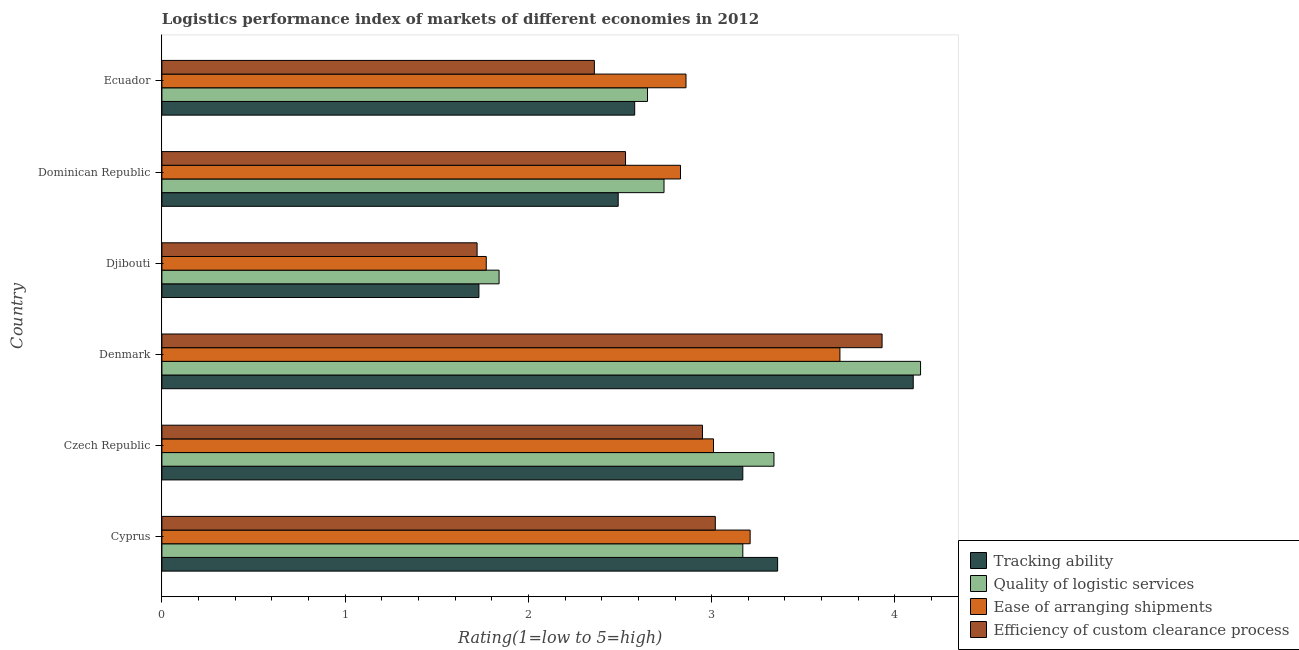How many groups of bars are there?
Give a very brief answer. 6. Are the number of bars per tick equal to the number of legend labels?
Provide a succinct answer. Yes. What is the label of the 2nd group of bars from the top?
Your answer should be compact. Dominican Republic. In how many cases, is the number of bars for a given country not equal to the number of legend labels?
Offer a very short reply. 0. What is the lpi rating of tracking ability in Czech Republic?
Your answer should be compact. 3.17. Across all countries, what is the maximum lpi rating of quality of logistic services?
Give a very brief answer. 4.14. Across all countries, what is the minimum lpi rating of ease of arranging shipments?
Offer a terse response. 1.77. In which country was the lpi rating of quality of logistic services minimum?
Ensure brevity in your answer.  Djibouti. What is the total lpi rating of quality of logistic services in the graph?
Offer a terse response. 17.88. What is the difference between the lpi rating of efficiency of custom clearance process in Denmark and that in Djibouti?
Provide a succinct answer. 2.21. What is the difference between the lpi rating of ease of arranging shipments in Dominican Republic and the lpi rating of tracking ability in Denmark?
Your answer should be compact. -1.27. What is the average lpi rating of efficiency of custom clearance process per country?
Offer a very short reply. 2.75. What is the difference between the lpi rating of quality of logistic services and lpi rating of ease of arranging shipments in Ecuador?
Your answer should be compact. -0.21. What is the ratio of the lpi rating of ease of arranging shipments in Djibouti to that in Dominican Republic?
Ensure brevity in your answer.  0.62. Is the lpi rating of efficiency of custom clearance process in Denmark less than that in Dominican Republic?
Make the answer very short. No. Is the difference between the lpi rating of efficiency of custom clearance process in Czech Republic and Denmark greater than the difference between the lpi rating of ease of arranging shipments in Czech Republic and Denmark?
Ensure brevity in your answer.  No. What is the difference between the highest and the second highest lpi rating of ease of arranging shipments?
Your answer should be very brief. 0.49. What is the difference between the highest and the lowest lpi rating of efficiency of custom clearance process?
Give a very brief answer. 2.21. In how many countries, is the lpi rating of quality of logistic services greater than the average lpi rating of quality of logistic services taken over all countries?
Give a very brief answer. 3. Is the sum of the lpi rating of tracking ability in Djibouti and Dominican Republic greater than the maximum lpi rating of ease of arranging shipments across all countries?
Provide a short and direct response. Yes. Is it the case that in every country, the sum of the lpi rating of ease of arranging shipments and lpi rating of tracking ability is greater than the sum of lpi rating of efficiency of custom clearance process and lpi rating of quality of logistic services?
Offer a very short reply. No. What does the 4th bar from the top in Dominican Republic represents?
Ensure brevity in your answer.  Tracking ability. What does the 4th bar from the bottom in Djibouti represents?
Your answer should be compact. Efficiency of custom clearance process. How many countries are there in the graph?
Give a very brief answer. 6. What is the difference between two consecutive major ticks on the X-axis?
Offer a very short reply. 1. Where does the legend appear in the graph?
Ensure brevity in your answer.  Bottom right. How are the legend labels stacked?
Your answer should be compact. Vertical. What is the title of the graph?
Offer a terse response. Logistics performance index of markets of different economies in 2012. Does "European Union" appear as one of the legend labels in the graph?
Keep it short and to the point. No. What is the label or title of the X-axis?
Your answer should be compact. Rating(1=low to 5=high). What is the Rating(1=low to 5=high) of Tracking ability in Cyprus?
Make the answer very short. 3.36. What is the Rating(1=low to 5=high) of Quality of logistic services in Cyprus?
Give a very brief answer. 3.17. What is the Rating(1=low to 5=high) of Ease of arranging shipments in Cyprus?
Keep it short and to the point. 3.21. What is the Rating(1=low to 5=high) of Efficiency of custom clearance process in Cyprus?
Keep it short and to the point. 3.02. What is the Rating(1=low to 5=high) of Tracking ability in Czech Republic?
Ensure brevity in your answer.  3.17. What is the Rating(1=low to 5=high) in Quality of logistic services in Czech Republic?
Make the answer very short. 3.34. What is the Rating(1=low to 5=high) in Ease of arranging shipments in Czech Republic?
Provide a short and direct response. 3.01. What is the Rating(1=low to 5=high) of Efficiency of custom clearance process in Czech Republic?
Offer a terse response. 2.95. What is the Rating(1=low to 5=high) of Tracking ability in Denmark?
Your response must be concise. 4.1. What is the Rating(1=low to 5=high) of Quality of logistic services in Denmark?
Make the answer very short. 4.14. What is the Rating(1=low to 5=high) of Ease of arranging shipments in Denmark?
Keep it short and to the point. 3.7. What is the Rating(1=low to 5=high) in Efficiency of custom clearance process in Denmark?
Keep it short and to the point. 3.93. What is the Rating(1=low to 5=high) in Tracking ability in Djibouti?
Your answer should be very brief. 1.73. What is the Rating(1=low to 5=high) of Quality of logistic services in Djibouti?
Your answer should be very brief. 1.84. What is the Rating(1=low to 5=high) in Ease of arranging shipments in Djibouti?
Ensure brevity in your answer.  1.77. What is the Rating(1=low to 5=high) in Efficiency of custom clearance process in Djibouti?
Provide a short and direct response. 1.72. What is the Rating(1=low to 5=high) in Tracking ability in Dominican Republic?
Give a very brief answer. 2.49. What is the Rating(1=low to 5=high) in Quality of logistic services in Dominican Republic?
Ensure brevity in your answer.  2.74. What is the Rating(1=low to 5=high) in Ease of arranging shipments in Dominican Republic?
Make the answer very short. 2.83. What is the Rating(1=low to 5=high) of Efficiency of custom clearance process in Dominican Republic?
Give a very brief answer. 2.53. What is the Rating(1=low to 5=high) of Tracking ability in Ecuador?
Provide a succinct answer. 2.58. What is the Rating(1=low to 5=high) in Quality of logistic services in Ecuador?
Offer a very short reply. 2.65. What is the Rating(1=low to 5=high) in Ease of arranging shipments in Ecuador?
Offer a very short reply. 2.86. What is the Rating(1=low to 5=high) in Efficiency of custom clearance process in Ecuador?
Ensure brevity in your answer.  2.36. Across all countries, what is the maximum Rating(1=low to 5=high) in Quality of logistic services?
Provide a short and direct response. 4.14. Across all countries, what is the maximum Rating(1=low to 5=high) in Ease of arranging shipments?
Make the answer very short. 3.7. Across all countries, what is the maximum Rating(1=low to 5=high) in Efficiency of custom clearance process?
Keep it short and to the point. 3.93. Across all countries, what is the minimum Rating(1=low to 5=high) in Tracking ability?
Keep it short and to the point. 1.73. Across all countries, what is the minimum Rating(1=low to 5=high) in Quality of logistic services?
Offer a very short reply. 1.84. Across all countries, what is the minimum Rating(1=low to 5=high) of Ease of arranging shipments?
Ensure brevity in your answer.  1.77. Across all countries, what is the minimum Rating(1=low to 5=high) in Efficiency of custom clearance process?
Your answer should be very brief. 1.72. What is the total Rating(1=low to 5=high) in Tracking ability in the graph?
Give a very brief answer. 17.43. What is the total Rating(1=low to 5=high) in Quality of logistic services in the graph?
Provide a short and direct response. 17.88. What is the total Rating(1=low to 5=high) of Ease of arranging shipments in the graph?
Offer a terse response. 17.38. What is the total Rating(1=low to 5=high) of Efficiency of custom clearance process in the graph?
Keep it short and to the point. 16.51. What is the difference between the Rating(1=low to 5=high) of Tracking ability in Cyprus and that in Czech Republic?
Provide a short and direct response. 0.19. What is the difference between the Rating(1=low to 5=high) in Quality of logistic services in Cyprus and that in Czech Republic?
Offer a terse response. -0.17. What is the difference between the Rating(1=low to 5=high) in Efficiency of custom clearance process in Cyprus and that in Czech Republic?
Your answer should be compact. 0.07. What is the difference between the Rating(1=low to 5=high) in Tracking ability in Cyprus and that in Denmark?
Give a very brief answer. -0.74. What is the difference between the Rating(1=low to 5=high) of Quality of logistic services in Cyprus and that in Denmark?
Offer a very short reply. -0.97. What is the difference between the Rating(1=low to 5=high) of Ease of arranging shipments in Cyprus and that in Denmark?
Your response must be concise. -0.49. What is the difference between the Rating(1=low to 5=high) of Efficiency of custom clearance process in Cyprus and that in Denmark?
Offer a terse response. -0.91. What is the difference between the Rating(1=low to 5=high) in Tracking ability in Cyprus and that in Djibouti?
Make the answer very short. 1.63. What is the difference between the Rating(1=low to 5=high) in Quality of logistic services in Cyprus and that in Djibouti?
Keep it short and to the point. 1.33. What is the difference between the Rating(1=low to 5=high) of Ease of arranging shipments in Cyprus and that in Djibouti?
Your response must be concise. 1.44. What is the difference between the Rating(1=low to 5=high) of Efficiency of custom clearance process in Cyprus and that in Djibouti?
Your answer should be very brief. 1.3. What is the difference between the Rating(1=low to 5=high) in Tracking ability in Cyprus and that in Dominican Republic?
Offer a terse response. 0.87. What is the difference between the Rating(1=low to 5=high) in Quality of logistic services in Cyprus and that in Dominican Republic?
Your answer should be very brief. 0.43. What is the difference between the Rating(1=low to 5=high) in Ease of arranging shipments in Cyprus and that in Dominican Republic?
Your answer should be compact. 0.38. What is the difference between the Rating(1=low to 5=high) of Efficiency of custom clearance process in Cyprus and that in Dominican Republic?
Ensure brevity in your answer.  0.49. What is the difference between the Rating(1=low to 5=high) in Tracking ability in Cyprus and that in Ecuador?
Give a very brief answer. 0.78. What is the difference between the Rating(1=low to 5=high) in Quality of logistic services in Cyprus and that in Ecuador?
Provide a short and direct response. 0.52. What is the difference between the Rating(1=low to 5=high) of Ease of arranging shipments in Cyprus and that in Ecuador?
Provide a succinct answer. 0.35. What is the difference between the Rating(1=low to 5=high) in Efficiency of custom clearance process in Cyprus and that in Ecuador?
Give a very brief answer. 0.66. What is the difference between the Rating(1=low to 5=high) of Tracking ability in Czech Republic and that in Denmark?
Keep it short and to the point. -0.93. What is the difference between the Rating(1=low to 5=high) in Ease of arranging shipments in Czech Republic and that in Denmark?
Keep it short and to the point. -0.69. What is the difference between the Rating(1=low to 5=high) in Efficiency of custom clearance process in Czech Republic and that in Denmark?
Offer a terse response. -0.98. What is the difference between the Rating(1=low to 5=high) in Tracking ability in Czech Republic and that in Djibouti?
Your answer should be compact. 1.44. What is the difference between the Rating(1=low to 5=high) of Ease of arranging shipments in Czech Republic and that in Djibouti?
Provide a succinct answer. 1.24. What is the difference between the Rating(1=low to 5=high) in Efficiency of custom clearance process in Czech Republic and that in Djibouti?
Make the answer very short. 1.23. What is the difference between the Rating(1=low to 5=high) of Tracking ability in Czech Republic and that in Dominican Republic?
Offer a very short reply. 0.68. What is the difference between the Rating(1=low to 5=high) in Quality of logistic services in Czech Republic and that in Dominican Republic?
Your answer should be very brief. 0.6. What is the difference between the Rating(1=low to 5=high) of Ease of arranging shipments in Czech Republic and that in Dominican Republic?
Your answer should be compact. 0.18. What is the difference between the Rating(1=low to 5=high) in Efficiency of custom clearance process in Czech Republic and that in Dominican Republic?
Provide a succinct answer. 0.42. What is the difference between the Rating(1=low to 5=high) in Tracking ability in Czech Republic and that in Ecuador?
Ensure brevity in your answer.  0.59. What is the difference between the Rating(1=low to 5=high) in Quality of logistic services in Czech Republic and that in Ecuador?
Offer a terse response. 0.69. What is the difference between the Rating(1=low to 5=high) in Efficiency of custom clearance process in Czech Republic and that in Ecuador?
Ensure brevity in your answer.  0.59. What is the difference between the Rating(1=low to 5=high) of Tracking ability in Denmark and that in Djibouti?
Your answer should be very brief. 2.37. What is the difference between the Rating(1=low to 5=high) of Quality of logistic services in Denmark and that in Djibouti?
Your response must be concise. 2.3. What is the difference between the Rating(1=low to 5=high) of Ease of arranging shipments in Denmark and that in Djibouti?
Provide a succinct answer. 1.93. What is the difference between the Rating(1=low to 5=high) of Efficiency of custom clearance process in Denmark and that in Djibouti?
Make the answer very short. 2.21. What is the difference between the Rating(1=low to 5=high) in Tracking ability in Denmark and that in Dominican Republic?
Give a very brief answer. 1.61. What is the difference between the Rating(1=low to 5=high) of Quality of logistic services in Denmark and that in Dominican Republic?
Your answer should be very brief. 1.4. What is the difference between the Rating(1=low to 5=high) in Ease of arranging shipments in Denmark and that in Dominican Republic?
Keep it short and to the point. 0.87. What is the difference between the Rating(1=low to 5=high) in Tracking ability in Denmark and that in Ecuador?
Your response must be concise. 1.52. What is the difference between the Rating(1=low to 5=high) in Quality of logistic services in Denmark and that in Ecuador?
Offer a very short reply. 1.49. What is the difference between the Rating(1=low to 5=high) in Ease of arranging shipments in Denmark and that in Ecuador?
Give a very brief answer. 0.84. What is the difference between the Rating(1=low to 5=high) of Efficiency of custom clearance process in Denmark and that in Ecuador?
Ensure brevity in your answer.  1.57. What is the difference between the Rating(1=low to 5=high) in Tracking ability in Djibouti and that in Dominican Republic?
Give a very brief answer. -0.76. What is the difference between the Rating(1=low to 5=high) of Ease of arranging shipments in Djibouti and that in Dominican Republic?
Make the answer very short. -1.06. What is the difference between the Rating(1=low to 5=high) in Efficiency of custom clearance process in Djibouti and that in Dominican Republic?
Provide a succinct answer. -0.81. What is the difference between the Rating(1=low to 5=high) of Tracking ability in Djibouti and that in Ecuador?
Offer a very short reply. -0.85. What is the difference between the Rating(1=low to 5=high) in Quality of logistic services in Djibouti and that in Ecuador?
Provide a short and direct response. -0.81. What is the difference between the Rating(1=low to 5=high) in Ease of arranging shipments in Djibouti and that in Ecuador?
Give a very brief answer. -1.09. What is the difference between the Rating(1=low to 5=high) in Efficiency of custom clearance process in Djibouti and that in Ecuador?
Your answer should be very brief. -0.64. What is the difference between the Rating(1=low to 5=high) of Tracking ability in Dominican Republic and that in Ecuador?
Offer a terse response. -0.09. What is the difference between the Rating(1=low to 5=high) in Quality of logistic services in Dominican Republic and that in Ecuador?
Your response must be concise. 0.09. What is the difference between the Rating(1=low to 5=high) of Ease of arranging shipments in Dominican Republic and that in Ecuador?
Provide a succinct answer. -0.03. What is the difference between the Rating(1=low to 5=high) of Efficiency of custom clearance process in Dominican Republic and that in Ecuador?
Your answer should be very brief. 0.17. What is the difference between the Rating(1=low to 5=high) in Tracking ability in Cyprus and the Rating(1=low to 5=high) in Efficiency of custom clearance process in Czech Republic?
Provide a short and direct response. 0.41. What is the difference between the Rating(1=low to 5=high) in Quality of logistic services in Cyprus and the Rating(1=low to 5=high) in Ease of arranging shipments in Czech Republic?
Provide a succinct answer. 0.16. What is the difference between the Rating(1=low to 5=high) of Quality of logistic services in Cyprus and the Rating(1=low to 5=high) of Efficiency of custom clearance process in Czech Republic?
Keep it short and to the point. 0.22. What is the difference between the Rating(1=low to 5=high) in Ease of arranging shipments in Cyprus and the Rating(1=low to 5=high) in Efficiency of custom clearance process in Czech Republic?
Your response must be concise. 0.26. What is the difference between the Rating(1=low to 5=high) of Tracking ability in Cyprus and the Rating(1=low to 5=high) of Quality of logistic services in Denmark?
Provide a short and direct response. -0.78. What is the difference between the Rating(1=low to 5=high) of Tracking ability in Cyprus and the Rating(1=low to 5=high) of Ease of arranging shipments in Denmark?
Offer a very short reply. -0.34. What is the difference between the Rating(1=low to 5=high) of Tracking ability in Cyprus and the Rating(1=low to 5=high) of Efficiency of custom clearance process in Denmark?
Provide a short and direct response. -0.57. What is the difference between the Rating(1=low to 5=high) of Quality of logistic services in Cyprus and the Rating(1=low to 5=high) of Ease of arranging shipments in Denmark?
Keep it short and to the point. -0.53. What is the difference between the Rating(1=low to 5=high) in Quality of logistic services in Cyprus and the Rating(1=low to 5=high) in Efficiency of custom clearance process in Denmark?
Your answer should be very brief. -0.76. What is the difference between the Rating(1=low to 5=high) in Ease of arranging shipments in Cyprus and the Rating(1=low to 5=high) in Efficiency of custom clearance process in Denmark?
Offer a terse response. -0.72. What is the difference between the Rating(1=low to 5=high) of Tracking ability in Cyprus and the Rating(1=low to 5=high) of Quality of logistic services in Djibouti?
Your answer should be very brief. 1.52. What is the difference between the Rating(1=low to 5=high) of Tracking ability in Cyprus and the Rating(1=low to 5=high) of Ease of arranging shipments in Djibouti?
Make the answer very short. 1.59. What is the difference between the Rating(1=low to 5=high) of Tracking ability in Cyprus and the Rating(1=low to 5=high) of Efficiency of custom clearance process in Djibouti?
Offer a terse response. 1.64. What is the difference between the Rating(1=low to 5=high) of Quality of logistic services in Cyprus and the Rating(1=low to 5=high) of Efficiency of custom clearance process in Djibouti?
Provide a short and direct response. 1.45. What is the difference between the Rating(1=low to 5=high) of Ease of arranging shipments in Cyprus and the Rating(1=low to 5=high) of Efficiency of custom clearance process in Djibouti?
Make the answer very short. 1.49. What is the difference between the Rating(1=low to 5=high) in Tracking ability in Cyprus and the Rating(1=low to 5=high) in Quality of logistic services in Dominican Republic?
Your answer should be compact. 0.62. What is the difference between the Rating(1=low to 5=high) of Tracking ability in Cyprus and the Rating(1=low to 5=high) of Ease of arranging shipments in Dominican Republic?
Give a very brief answer. 0.53. What is the difference between the Rating(1=low to 5=high) of Tracking ability in Cyprus and the Rating(1=low to 5=high) of Efficiency of custom clearance process in Dominican Republic?
Your answer should be very brief. 0.83. What is the difference between the Rating(1=low to 5=high) in Quality of logistic services in Cyprus and the Rating(1=low to 5=high) in Ease of arranging shipments in Dominican Republic?
Ensure brevity in your answer.  0.34. What is the difference between the Rating(1=low to 5=high) of Quality of logistic services in Cyprus and the Rating(1=low to 5=high) of Efficiency of custom clearance process in Dominican Republic?
Offer a terse response. 0.64. What is the difference between the Rating(1=low to 5=high) of Ease of arranging shipments in Cyprus and the Rating(1=low to 5=high) of Efficiency of custom clearance process in Dominican Republic?
Provide a short and direct response. 0.68. What is the difference between the Rating(1=low to 5=high) in Tracking ability in Cyprus and the Rating(1=low to 5=high) in Quality of logistic services in Ecuador?
Ensure brevity in your answer.  0.71. What is the difference between the Rating(1=low to 5=high) of Quality of logistic services in Cyprus and the Rating(1=low to 5=high) of Ease of arranging shipments in Ecuador?
Your answer should be compact. 0.31. What is the difference between the Rating(1=low to 5=high) of Quality of logistic services in Cyprus and the Rating(1=low to 5=high) of Efficiency of custom clearance process in Ecuador?
Offer a very short reply. 0.81. What is the difference between the Rating(1=low to 5=high) of Tracking ability in Czech Republic and the Rating(1=low to 5=high) of Quality of logistic services in Denmark?
Make the answer very short. -0.97. What is the difference between the Rating(1=low to 5=high) of Tracking ability in Czech Republic and the Rating(1=low to 5=high) of Ease of arranging shipments in Denmark?
Keep it short and to the point. -0.53. What is the difference between the Rating(1=low to 5=high) in Tracking ability in Czech Republic and the Rating(1=low to 5=high) in Efficiency of custom clearance process in Denmark?
Provide a succinct answer. -0.76. What is the difference between the Rating(1=low to 5=high) of Quality of logistic services in Czech Republic and the Rating(1=low to 5=high) of Ease of arranging shipments in Denmark?
Provide a short and direct response. -0.36. What is the difference between the Rating(1=low to 5=high) of Quality of logistic services in Czech Republic and the Rating(1=low to 5=high) of Efficiency of custom clearance process in Denmark?
Your answer should be very brief. -0.59. What is the difference between the Rating(1=low to 5=high) in Ease of arranging shipments in Czech Republic and the Rating(1=low to 5=high) in Efficiency of custom clearance process in Denmark?
Keep it short and to the point. -0.92. What is the difference between the Rating(1=low to 5=high) of Tracking ability in Czech Republic and the Rating(1=low to 5=high) of Quality of logistic services in Djibouti?
Make the answer very short. 1.33. What is the difference between the Rating(1=low to 5=high) in Tracking ability in Czech Republic and the Rating(1=low to 5=high) in Efficiency of custom clearance process in Djibouti?
Ensure brevity in your answer.  1.45. What is the difference between the Rating(1=low to 5=high) in Quality of logistic services in Czech Republic and the Rating(1=low to 5=high) in Ease of arranging shipments in Djibouti?
Make the answer very short. 1.57. What is the difference between the Rating(1=low to 5=high) in Quality of logistic services in Czech Republic and the Rating(1=low to 5=high) in Efficiency of custom clearance process in Djibouti?
Provide a succinct answer. 1.62. What is the difference between the Rating(1=low to 5=high) of Ease of arranging shipments in Czech Republic and the Rating(1=low to 5=high) of Efficiency of custom clearance process in Djibouti?
Offer a terse response. 1.29. What is the difference between the Rating(1=low to 5=high) in Tracking ability in Czech Republic and the Rating(1=low to 5=high) in Quality of logistic services in Dominican Republic?
Give a very brief answer. 0.43. What is the difference between the Rating(1=low to 5=high) of Tracking ability in Czech Republic and the Rating(1=low to 5=high) of Ease of arranging shipments in Dominican Republic?
Offer a terse response. 0.34. What is the difference between the Rating(1=low to 5=high) of Tracking ability in Czech Republic and the Rating(1=low to 5=high) of Efficiency of custom clearance process in Dominican Republic?
Your answer should be compact. 0.64. What is the difference between the Rating(1=low to 5=high) in Quality of logistic services in Czech Republic and the Rating(1=low to 5=high) in Ease of arranging shipments in Dominican Republic?
Make the answer very short. 0.51. What is the difference between the Rating(1=low to 5=high) in Quality of logistic services in Czech Republic and the Rating(1=low to 5=high) in Efficiency of custom clearance process in Dominican Republic?
Keep it short and to the point. 0.81. What is the difference between the Rating(1=low to 5=high) in Ease of arranging shipments in Czech Republic and the Rating(1=low to 5=high) in Efficiency of custom clearance process in Dominican Republic?
Provide a succinct answer. 0.48. What is the difference between the Rating(1=low to 5=high) of Tracking ability in Czech Republic and the Rating(1=low to 5=high) of Quality of logistic services in Ecuador?
Provide a short and direct response. 0.52. What is the difference between the Rating(1=low to 5=high) of Tracking ability in Czech Republic and the Rating(1=low to 5=high) of Ease of arranging shipments in Ecuador?
Ensure brevity in your answer.  0.31. What is the difference between the Rating(1=low to 5=high) in Tracking ability in Czech Republic and the Rating(1=low to 5=high) in Efficiency of custom clearance process in Ecuador?
Keep it short and to the point. 0.81. What is the difference between the Rating(1=low to 5=high) in Quality of logistic services in Czech Republic and the Rating(1=low to 5=high) in Ease of arranging shipments in Ecuador?
Make the answer very short. 0.48. What is the difference between the Rating(1=low to 5=high) of Quality of logistic services in Czech Republic and the Rating(1=low to 5=high) of Efficiency of custom clearance process in Ecuador?
Offer a terse response. 0.98. What is the difference between the Rating(1=low to 5=high) in Ease of arranging shipments in Czech Republic and the Rating(1=low to 5=high) in Efficiency of custom clearance process in Ecuador?
Offer a terse response. 0.65. What is the difference between the Rating(1=low to 5=high) of Tracking ability in Denmark and the Rating(1=low to 5=high) of Quality of logistic services in Djibouti?
Give a very brief answer. 2.26. What is the difference between the Rating(1=low to 5=high) of Tracking ability in Denmark and the Rating(1=low to 5=high) of Ease of arranging shipments in Djibouti?
Give a very brief answer. 2.33. What is the difference between the Rating(1=low to 5=high) of Tracking ability in Denmark and the Rating(1=low to 5=high) of Efficiency of custom clearance process in Djibouti?
Make the answer very short. 2.38. What is the difference between the Rating(1=low to 5=high) in Quality of logistic services in Denmark and the Rating(1=low to 5=high) in Ease of arranging shipments in Djibouti?
Your response must be concise. 2.37. What is the difference between the Rating(1=low to 5=high) in Quality of logistic services in Denmark and the Rating(1=low to 5=high) in Efficiency of custom clearance process in Djibouti?
Provide a succinct answer. 2.42. What is the difference between the Rating(1=low to 5=high) in Ease of arranging shipments in Denmark and the Rating(1=low to 5=high) in Efficiency of custom clearance process in Djibouti?
Make the answer very short. 1.98. What is the difference between the Rating(1=low to 5=high) of Tracking ability in Denmark and the Rating(1=low to 5=high) of Quality of logistic services in Dominican Republic?
Offer a very short reply. 1.36. What is the difference between the Rating(1=low to 5=high) in Tracking ability in Denmark and the Rating(1=low to 5=high) in Ease of arranging shipments in Dominican Republic?
Your response must be concise. 1.27. What is the difference between the Rating(1=low to 5=high) of Tracking ability in Denmark and the Rating(1=low to 5=high) of Efficiency of custom clearance process in Dominican Republic?
Give a very brief answer. 1.57. What is the difference between the Rating(1=low to 5=high) in Quality of logistic services in Denmark and the Rating(1=low to 5=high) in Ease of arranging shipments in Dominican Republic?
Provide a succinct answer. 1.31. What is the difference between the Rating(1=low to 5=high) in Quality of logistic services in Denmark and the Rating(1=low to 5=high) in Efficiency of custom clearance process in Dominican Republic?
Your answer should be compact. 1.61. What is the difference between the Rating(1=low to 5=high) of Ease of arranging shipments in Denmark and the Rating(1=low to 5=high) of Efficiency of custom clearance process in Dominican Republic?
Offer a very short reply. 1.17. What is the difference between the Rating(1=low to 5=high) of Tracking ability in Denmark and the Rating(1=low to 5=high) of Quality of logistic services in Ecuador?
Your answer should be compact. 1.45. What is the difference between the Rating(1=low to 5=high) of Tracking ability in Denmark and the Rating(1=low to 5=high) of Ease of arranging shipments in Ecuador?
Offer a very short reply. 1.24. What is the difference between the Rating(1=low to 5=high) of Tracking ability in Denmark and the Rating(1=low to 5=high) of Efficiency of custom clearance process in Ecuador?
Provide a short and direct response. 1.74. What is the difference between the Rating(1=low to 5=high) in Quality of logistic services in Denmark and the Rating(1=low to 5=high) in Ease of arranging shipments in Ecuador?
Offer a very short reply. 1.28. What is the difference between the Rating(1=low to 5=high) in Quality of logistic services in Denmark and the Rating(1=low to 5=high) in Efficiency of custom clearance process in Ecuador?
Give a very brief answer. 1.78. What is the difference between the Rating(1=low to 5=high) in Ease of arranging shipments in Denmark and the Rating(1=low to 5=high) in Efficiency of custom clearance process in Ecuador?
Offer a terse response. 1.34. What is the difference between the Rating(1=low to 5=high) in Tracking ability in Djibouti and the Rating(1=low to 5=high) in Quality of logistic services in Dominican Republic?
Provide a succinct answer. -1.01. What is the difference between the Rating(1=low to 5=high) in Tracking ability in Djibouti and the Rating(1=low to 5=high) in Ease of arranging shipments in Dominican Republic?
Provide a succinct answer. -1.1. What is the difference between the Rating(1=low to 5=high) in Tracking ability in Djibouti and the Rating(1=low to 5=high) in Efficiency of custom clearance process in Dominican Republic?
Keep it short and to the point. -0.8. What is the difference between the Rating(1=low to 5=high) of Quality of logistic services in Djibouti and the Rating(1=low to 5=high) of Ease of arranging shipments in Dominican Republic?
Offer a terse response. -0.99. What is the difference between the Rating(1=low to 5=high) of Quality of logistic services in Djibouti and the Rating(1=low to 5=high) of Efficiency of custom clearance process in Dominican Republic?
Keep it short and to the point. -0.69. What is the difference between the Rating(1=low to 5=high) of Ease of arranging shipments in Djibouti and the Rating(1=low to 5=high) of Efficiency of custom clearance process in Dominican Republic?
Provide a short and direct response. -0.76. What is the difference between the Rating(1=low to 5=high) of Tracking ability in Djibouti and the Rating(1=low to 5=high) of Quality of logistic services in Ecuador?
Offer a terse response. -0.92. What is the difference between the Rating(1=low to 5=high) in Tracking ability in Djibouti and the Rating(1=low to 5=high) in Ease of arranging shipments in Ecuador?
Your answer should be compact. -1.13. What is the difference between the Rating(1=low to 5=high) of Tracking ability in Djibouti and the Rating(1=low to 5=high) of Efficiency of custom clearance process in Ecuador?
Provide a short and direct response. -0.63. What is the difference between the Rating(1=low to 5=high) of Quality of logistic services in Djibouti and the Rating(1=low to 5=high) of Ease of arranging shipments in Ecuador?
Make the answer very short. -1.02. What is the difference between the Rating(1=low to 5=high) in Quality of logistic services in Djibouti and the Rating(1=low to 5=high) in Efficiency of custom clearance process in Ecuador?
Your answer should be very brief. -0.52. What is the difference between the Rating(1=low to 5=high) in Ease of arranging shipments in Djibouti and the Rating(1=low to 5=high) in Efficiency of custom clearance process in Ecuador?
Keep it short and to the point. -0.59. What is the difference between the Rating(1=low to 5=high) of Tracking ability in Dominican Republic and the Rating(1=low to 5=high) of Quality of logistic services in Ecuador?
Keep it short and to the point. -0.16. What is the difference between the Rating(1=low to 5=high) in Tracking ability in Dominican Republic and the Rating(1=low to 5=high) in Ease of arranging shipments in Ecuador?
Your answer should be very brief. -0.37. What is the difference between the Rating(1=low to 5=high) of Tracking ability in Dominican Republic and the Rating(1=low to 5=high) of Efficiency of custom clearance process in Ecuador?
Provide a succinct answer. 0.13. What is the difference between the Rating(1=low to 5=high) in Quality of logistic services in Dominican Republic and the Rating(1=low to 5=high) in Ease of arranging shipments in Ecuador?
Provide a short and direct response. -0.12. What is the difference between the Rating(1=low to 5=high) of Quality of logistic services in Dominican Republic and the Rating(1=low to 5=high) of Efficiency of custom clearance process in Ecuador?
Your answer should be very brief. 0.38. What is the difference between the Rating(1=low to 5=high) of Ease of arranging shipments in Dominican Republic and the Rating(1=low to 5=high) of Efficiency of custom clearance process in Ecuador?
Offer a very short reply. 0.47. What is the average Rating(1=low to 5=high) of Tracking ability per country?
Offer a terse response. 2.9. What is the average Rating(1=low to 5=high) in Quality of logistic services per country?
Make the answer very short. 2.98. What is the average Rating(1=low to 5=high) in Ease of arranging shipments per country?
Provide a succinct answer. 2.9. What is the average Rating(1=low to 5=high) in Efficiency of custom clearance process per country?
Your answer should be very brief. 2.75. What is the difference between the Rating(1=low to 5=high) in Tracking ability and Rating(1=low to 5=high) in Quality of logistic services in Cyprus?
Offer a very short reply. 0.19. What is the difference between the Rating(1=low to 5=high) in Tracking ability and Rating(1=low to 5=high) in Efficiency of custom clearance process in Cyprus?
Your answer should be compact. 0.34. What is the difference between the Rating(1=low to 5=high) of Quality of logistic services and Rating(1=low to 5=high) of Ease of arranging shipments in Cyprus?
Provide a succinct answer. -0.04. What is the difference between the Rating(1=low to 5=high) in Quality of logistic services and Rating(1=low to 5=high) in Efficiency of custom clearance process in Cyprus?
Keep it short and to the point. 0.15. What is the difference between the Rating(1=low to 5=high) in Ease of arranging shipments and Rating(1=low to 5=high) in Efficiency of custom clearance process in Cyprus?
Offer a terse response. 0.19. What is the difference between the Rating(1=low to 5=high) of Tracking ability and Rating(1=low to 5=high) of Quality of logistic services in Czech Republic?
Keep it short and to the point. -0.17. What is the difference between the Rating(1=low to 5=high) in Tracking ability and Rating(1=low to 5=high) in Ease of arranging shipments in Czech Republic?
Ensure brevity in your answer.  0.16. What is the difference between the Rating(1=low to 5=high) in Tracking ability and Rating(1=low to 5=high) in Efficiency of custom clearance process in Czech Republic?
Ensure brevity in your answer.  0.22. What is the difference between the Rating(1=low to 5=high) in Quality of logistic services and Rating(1=low to 5=high) in Ease of arranging shipments in Czech Republic?
Your response must be concise. 0.33. What is the difference between the Rating(1=low to 5=high) of Quality of logistic services and Rating(1=low to 5=high) of Efficiency of custom clearance process in Czech Republic?
Ensure brevity in your answer.  0.39. What is the difference between the Rating(1=low to 5=high) of Ease of arranging shipments and Rating(1=low to 5=high) of Efficiency of custom clearance process in Czech Republic?
Offer a terse response. 0.06. What is the difference between the Rating(1=low to 5=high) in Tracking ability and Rating(1=low to 5=high) in Quality of logistic services in Denmark?
Offer a terse response. -0.04. What is the difference between the Rating(1=low to 5=high) of Tracking ability and Rating(1=low to 5=high) of Efficiency of custom clearance process in Denmark?
Offer a very short reply. 0.17. What is the difference between the Rating(1=low to 5=high) of Quality of logistic services and Rating(1=low to 5=high) of Ease of arranging shipments in Denmark?
Provide a short and direct response. 0.44. What is the difference between the Rating(1=low to 5=high) in Quality of logistic services and Rating(1=low to 5=high) in Efficiency of custom clearance process in Denmark?
Make the answer very short. 0.21. What is the difference between the Rating(1=low to 5=high) in Ease of arranging shipments and Rating(1=low to 5=high) in Efficiency of custom clearance process in Denmark?
Provide a succinct answer. -0.23. What is the difference between the Rating(1=low to 5=high) of Tracking ability and Rating(1=low to 5=high) of Quality of logistic services in Djibouti?
Keep it short and to the point. -0.11. What is the difference between the Rating(1=low to 5=high) in Tracking ability and Rating(1=low to 5=high) in Ease of arranging shipments in Djibouti?
Your response must be concise. -0.04. What is the difference between the Rating(1=low to 5=high) in Quality of logistic services and Rating(1=low to 5=high) in Ease of arranging shipments in Djibouti?
Your answer should be very brief. 0.07. What is the difference between the Rating(1=low to 5=high) of Quality of logistic services and Rating(1=low to 5=high) of Efficiency of custom clearance process in Djibouti?
Offer a very short reply. 0.12. What is the difference between the Rating(1=low to 5=high) of Ease of arranging shipments and Rating(1=low to 5=high) of Efficiency of custom clearance process in Djibouti?
Keep it short and to the point. 0.05. What is the difference between the Rating(1=low to 5=high) of Tracking ability and Rating(1=low to 5=high) of Quality of logistic services in Dominican Republic?
Ensure brevity in your answer.  -0.25. What is the difference between the Rating(1=low to 5=high) of Tracking ability and Rating(1=low to 5=high) of Ease of arranging shipments in Dominican Republic?
Give a very brief answer. -0.34. What is the difference between the Rating(1=low to 5=high) of Tracking ability and Rating(1=low to 5=high) of Efficiency of custom clearance process in Dominican Republic?
Make the answer very short. -0.04. What is the difference between the Rating(1=low to 5=high) in Quality of logistic services and Rating(1=low to 5=high) in Ease of arranging shipments in Dominican Republic?
Your answer should be very brief. -0.09. What is the difference between the Rating(1=low to 5=high) in Quality of logistic services and Rating(1=low to 5=high) in Efficiency of custom clearance process in Dominican Republic?
Offer a terse response. 0.21. What is the difference between the Rating(1=low to 5=high) of Ease of arranging shipments and Rating(1=low to 5=high) of Efficiency of custom clearance process in Dominican Republic?
Keep it short and to the point. 0.3. What is the difference between the Rating(1=low to 5=high) in Tracking ability and Rating(1=low to 5=high) in Quality of logistic services in Ecuador?
Offer a very short reply. -0.07. What is the difference between the Rating(1=low to 5=high) in Tracking ability and Rating(1=low to 5=high) in Ease of arranging shipments in Ecuador?
Provide a succinct answer. -0.28. What is the difference between the Rating(1=low to 5=high) in Tracking ability and Rating(1=low to 5=high) in Efficiency of custom clearance process in Ecuador?
Ensure brevity in your answer.  0.22. What is the difference between the Rating(1=low to 5=high) of Quality of logistic services and Rating(1=low to 5=high) of Ease of arranging shipments in Ecuador?
Keep it short and to the point. -0.21. What is the difference between the Rating(1=low to 5=high) of Quality of logistic services and Rating(1=low to 5=high) of Efficiency of custom clearance process in Ecuador?
Offer a terse response. 0.29. What is the difference between the Rating(1=low to 5=high) of Ease of arranging shipments and Rating(1=low to 5=high) of Efficiency of custom clearance process in Ecuador?
Provide a short and direct response. 0.5. What is the ratio of the Rating(1=low to 5=high) in Tracking ability in Cyprus to that in Czech Republic?
Your answer should be compact. 1.06. What is the ratio of the Rating(1=low to 5=high) in Quality of logistic services in Cyprus to that in Czech Republic?
Provide a succinct answer. 0.95. What is the ratio of the Rating(1=low to 5=high) in Ease of arranging shipments in Cyprus to that in Czech Republic?
Your response must be concise. 1.07. What is the ratio of the Rating(1=low to 5=high) in Efficiency of custom clearance process in Cyprus to that in Czech Republic?
Your answer should be very brief. 1.02. What is the ratio of the Rating(1=low to 5=high) of Tracking ability in Cyprus to that in Denmark?
Offer a very short reply. 0.82. What is the ratio of the Rating(1=low to 5=high) in Quality of logistic services in Cyprus to that in Denmark?
Keep it short and to the point. 0.77. What is the ratio of the Rating(1=low to 5=high) of Ease of arranging shipments in Cyprus to that in Denmark?
Provide a succinct answer. 0.87. What is the ratio of the Rating(1=low to 5=high) in Efficiency of custom clearance process in Cyprus to that in Denmark?
Offer a terse response. 0.77. What is the ratio of the Rating(1=low to 5=high) in Tracking ability in Cyprus to that in Djibouti?
Your answer should be compact. 1.94. What is the ratio of the Rating(1=low to 5=high) of Quality of logistic services in Cyprus to that in Djibouti?
Your answer should be very brief. 1.72. What is the ratio of the Rating(1=low to 5=high) in Ease of arranging shipments in Cyprus to that in Djibouti?
Your response must be concise. 1.81. What is the ratio of the Rating(1=low to 5=high) of Efficiency of custom clearance process in Cyprus to that in Djibouti?
Keep it short and to the point. 1.76. What is the ratio of the Rating(1=low to 5=high) of Tracking ability in Cyprus to that in Dominican Republic?
Your response must be concise. 1.35. What is the ratio of the Rating(1=low to 5=high) in Quality of logistic services in Cyprus to that in Dominican Republic?
Offer a very short reply. 1.16. What is the ratio of the Rating(1=low to 5=high) in Ease of arranging shipments in Cyprus to that in Dominican Republic?
Offer a very short reply. 1.13. What is the ratio of the Rating(1=low to 5=high) in Efficiency of custom clearance process in Cyprus to that in Dominican Republic?
Your answer should be compact. 1.19. What is the ratio of the Rating(1=low to 5=high) in Tracking ability in Cyprus to that in Ecuador?
Keep it short and to the point. 1.3. What is the ratio of the Rating(1=low to 5=high) of Quality of logistic services in Cyprus to that in Ecuador?
Your response must be concise. 1.2. What is the ratio of the Rating(1=low to 5=high) in Ease of arranging shipments in Cyprus to that in Ecuador?
Your response must be concise. 1.12. What is the ratio of the Rating(1=low to 5=high) in Efficiency of custom clearance process in Cyprus to that in Ecuador?
Make the answer very short. 1.28. What is the ratio of the Rating(1=low to 5=high) in Tracking ability in Czech Republic to that in Denmark?
Offer a very short reply. 0.77. What is the ratio of the Rating(1=low to 5=high) in Quality of logistic services in Czech Republic to that in Denmark?
Your response must be concise. 0.81. What is the ratio of the Rating(1=low to 5=high) of Ease of arranging shipments in Czech Republic to that in Denmark?
Your response must be concise. 0.81. What is the ratio of the Rating(1=low to 5=high) in Efficiency of custom clearance process in Czech Republic to that in Denmark?
Make the answer very short. 0.75. What is the ratio of the Rating(1=low to 5=high) of Tracking ability in Czech Republic to that in Djibouti?
Ensure brevity in your answer.  1.83. What is the ratio of the Rating(1=low to 5=high) of Quality of logistic services in Czech Republic to that in Djibouti?
Give a very brief answer. 1.82. What is the ratio of the Rating(1=low to 5=high) of Ease of arranging shipments in Czech Republic to that in Djibouti?
Keep it short and to the point. 1.7. What is the ratio of the Rating(1=low to 5=high) of Efficiency of custom clearance process in Czech Republic to that in Djibouti?
Keep it short and to the point. 1.72. What is the ratio of the Rating(1=low to 5=high) of Tracking ability in Czech Republic to that in Dominican Republic?
Provide a short and direct response. 1.27. What is the ratio of the Rating(1=low to 5=high) in Quality of logistic services in Czech Republic to that in Dominican Republic?
Offer a very short reply. 1.22. What is the ratio of the Rating(1=low to 5=high) of Ease of arranging shipments in Czech Republic to that in Dominican Republic?
Your answer should be very brief. 1.06. What is the ratio of the Rating(1=low to 5=high) in Efficiency of custom clearance process in Czech Republic to that in Dominican Republic?
Your answer should be compact. 1.17. What is the ratio of the Rating(1=low to 5=high) of Tracking ability in Czech Republic to that in Ecuador?
Provide a succinct answer. 1.23. What is the ratio of the Rating(1=low to 5=high) of Quality of logistic services in Czech Republic to that in Ecuador?
Offer a very short reply. 1.26. What is the ratio of the Rating(1=low to 5=high) in Ease of arranging shipments in Czech Republic to that in Ecuador?
Keep it short and to the point. 1.05. What is the ratio of the Rating(1=low to 5=high) of Efficiency of custom clearance process in Czech Republic to that in Ecuador?
Keep it short and to the point. 1.25. What is the ratio of the Rating(1=low to 5=high) in Tracking ability in Denmark to that in Djibouti?
Make the answer very short. 2.37. What is the ratio of the Rating(1=low to 5=high) in Quality of logistic services in Denmark to that in Djibouti?
Your answer should be very brief. 2.25. What is the ratio of the Rating(1=low to 5=high) in Ease of arranging shipments in Denmark to that in Djibouti?
Give a very brief answer. 2.09. What is the ratio of the Rating(1=low to 5=high) in Efficiency of custom clearance process in Denmark to that in Djibouti?
Ensure brevity in your answer.  2.28. What is the ratio of the Rating(1=low to 5=high) of Tracking ability in Denmark to that in Dominican Republic?
Your answer should be compact. 1.65. What is the ratio of the Rating(1=low to 5=high) of Quality of logistic services in Denmark to that in Dominican Republic?
Keep it short and to the point. 1.51. What is the ratio of the Rating(1=low to 5=high) in Ease of arranging shipments in Denmark to that in Dominican Republic?
Give a very brief answer. 1.31. What is the ratio of the Rating(1=low to 5=high) of Efficiency of custom clearance process in Denmark to that in Dominican Republic?
Give a very brief answer. 1.55. What is the ratio of the Rating(1=low to 5=high) in Tracking ability in Denmark to that in Ecuador?
Make the answer very short. 1.59. What is the ratio of the Rating(1=low to 5=high) in Quality of logistic services in Denmark to that in Ecuador?
Your answer should be compact. 1.56. What is the ratio of the Rating(1=low to 5=high) of Ease of arranging shipments in Denmark to that in Ecuador?
Your response must be concise. 1.29. What is the ratio of the Rating(1=low to 5=high) of Efficiency of custom clearance process in Denmark to that in Ecuador?
Keep it short and to the point. 1.67. What is the ratio of the Rating(1=low to 5=high) in Tracking ability in Djibouti to that in Dominican Republic?
Make the answer very short. 0.69. What is the ratio of the Rating(1=low to 5=high) of Quality of logistic services in Djibouti to that in Dominican Republic?
Make the answer very short. 0.67. What is the ratio of the Rating(1=low to 5=high) in Ease of arranging shipments in Djibouti to that in Dominican Republic?
Provide a succinct answer. 0.63. What is the ratio of the Rating(1=low to 5=high) of Efficiency of custom clearance process in Djibouti to that in Dominican Republic?
Make the answer very short. 0.68. What is the ratio of the Rating(1=low to 5=high) in Tracking ability in Djibouti to that in Ecuador?
Your answer should be compact. 0.67. What is the ratio of the Rating(1=low to 5=high) of Quality of logistic services in Djibouti to that in Ecuador?
Your response must be concise. 0.69. What is the ratio of the Rating(1=low to 5=high) of Ease of arranging shipments in Djibouti to that in Ecuador?
Offer a terse response. 0.62. What is the ratio of the Rating(1=low to 5=high) in Efficiency of custom clearance process in Djibouti to that in Ecuador?
Ensure brevity in your answer.  0.73. What is the ratio of the Rating(1=low to 5=high) of Tracking ability in Dominican Republic to that in Ecuador?
Provide a short and direct response. 0.97. What is the ratio of the Rating(1=low to 5=high) in Quality of logistic services in Dominican Republic to that in Ecuador?
Offer a very short reply. 1.03. What is the ratio of the Rating(1=low to 5=high) of Ease of arranging shipments in Dominican Republic to that in Ecuador?
Offer a very short reply. 0.99. What is the ratio of the Rating(1=low to 5=high) of Efficiency of custom clearance process in Dominican Republic to that in Ecuador?
Offer a terse response. 1.07. What is the difference between the highest and the second highest Rating(1=low to 5=high) in Tracking ability?
Your answer should be very brief. 0.74. What is the difference between the highest and the second highest Rating(1=low to 5=high) of Quality of logistic services?
Offer a terse response. 0.8. What is the difference between the highest and the second highest Rating(1=low to 5=high) of Ease of arranging shipments?
Provide a succinct answer. 0.49. What is the difference between the highest and the second highest Rating(1=low to 5=high) in Efficiency of custom clearance process?
Your answer should be compact. 0.91. What is the difference between the highest and the lowest Rating(1=low to 5=high) in Tracking ability?
Provide a succinct answer. 2.37. What is the difference between the highest and the lowest Rating(1=low to 5=high) of Quality of logistic services?
Give a very brief answer. 2.3. What is the difference between the highest and the lowest Rating(1=low to 5=high) of Ease of arranging shipments?
Ensure brevity in your answer.  1.93. What is the difference between the highest and the lowest Rating(1=low to 5=high) of Efficiency of custom clearance process?
Your answer should be compact. 2.21. 